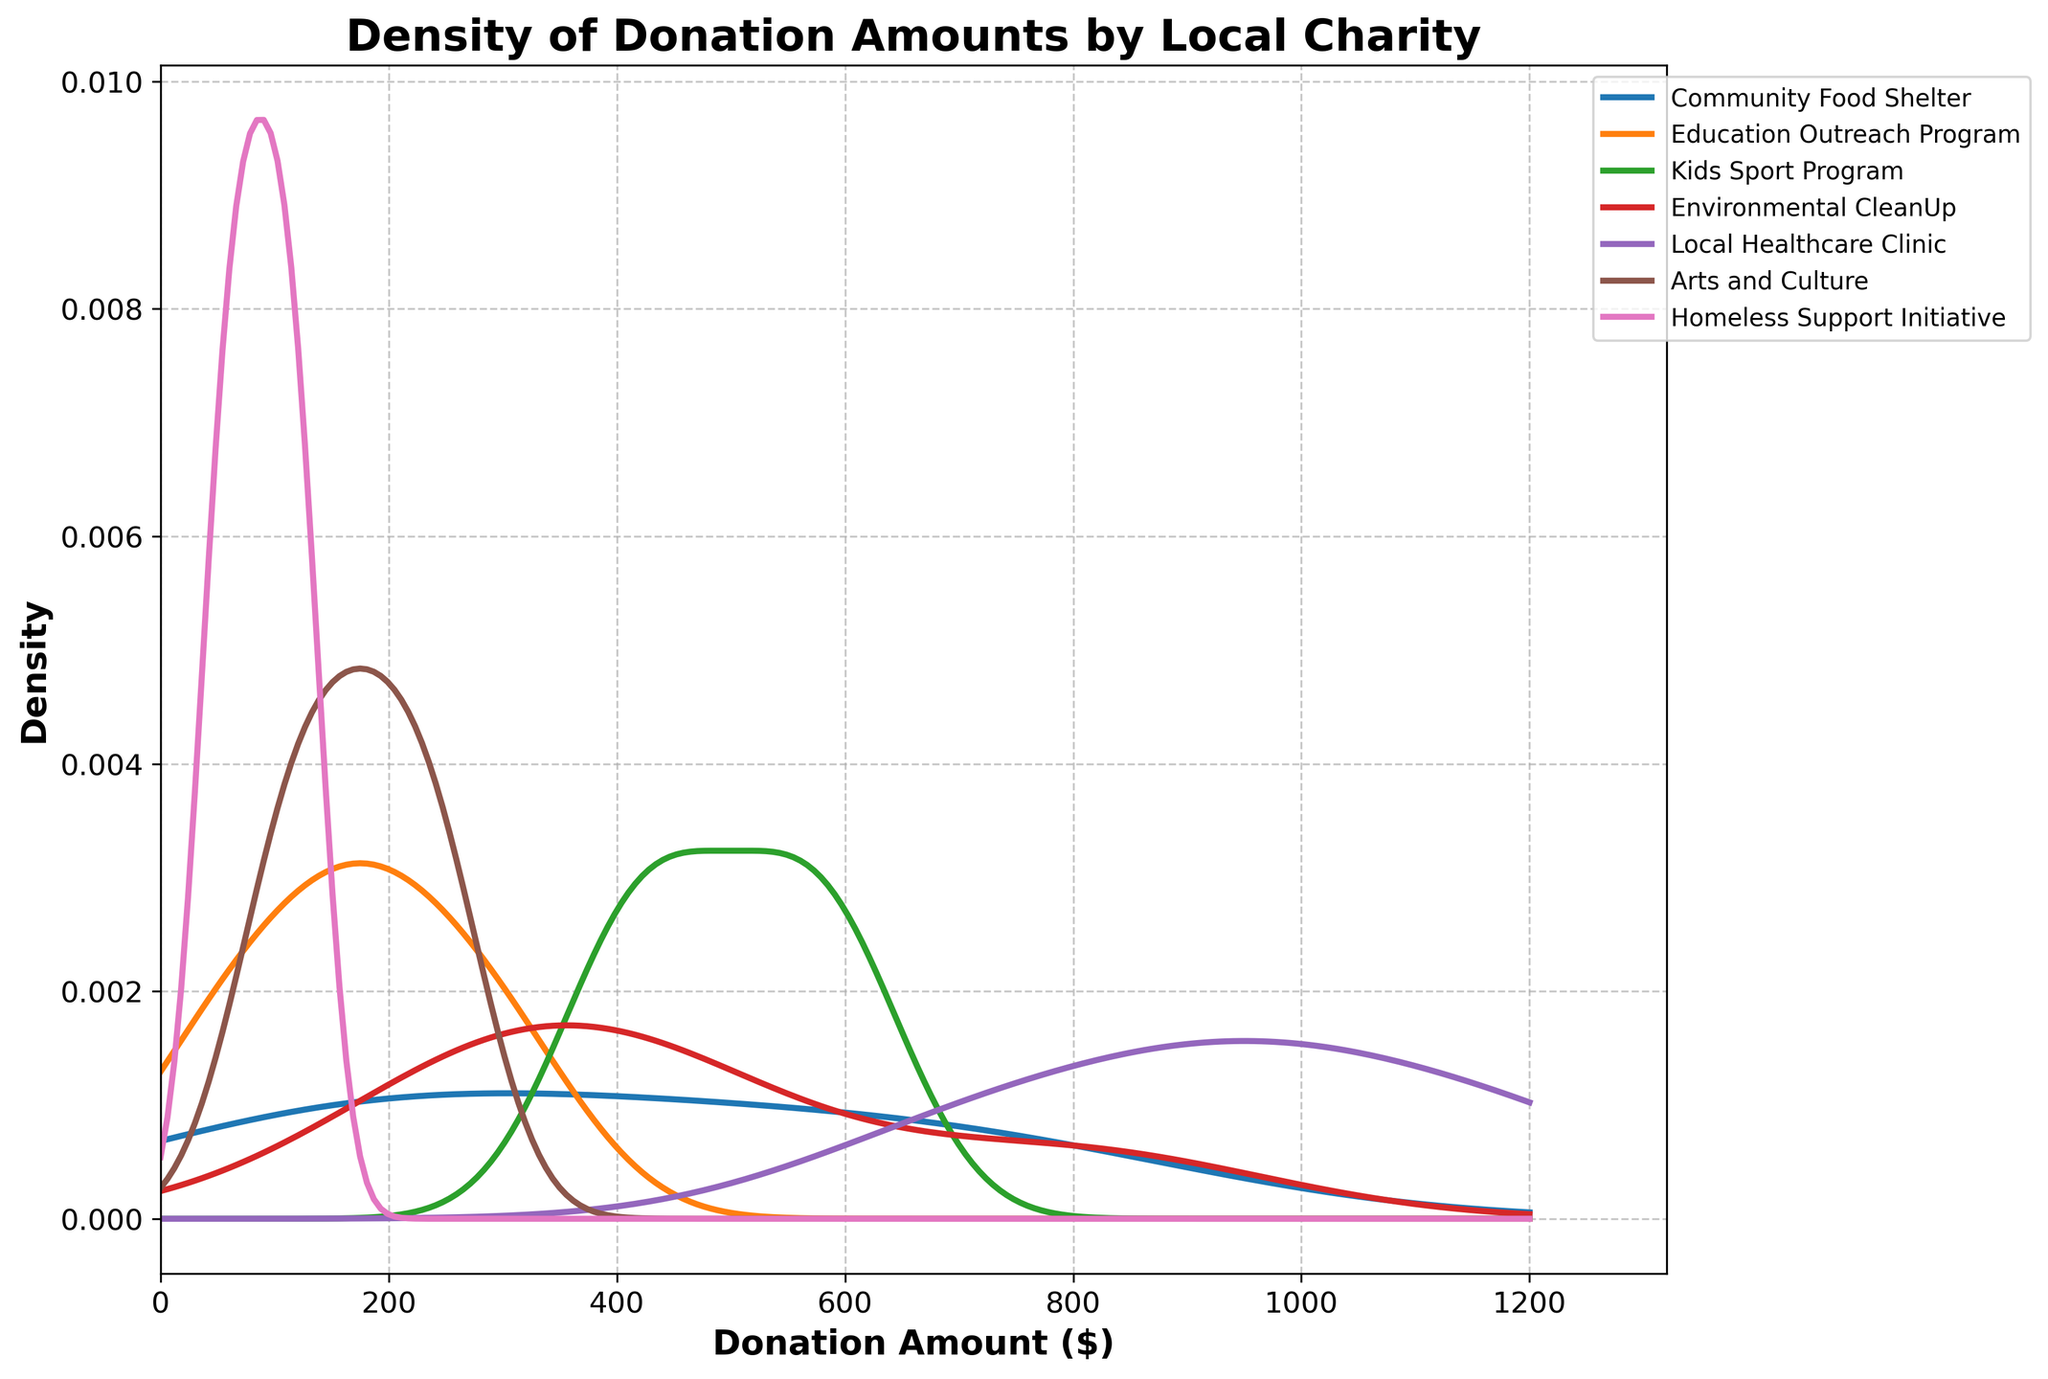What's the highest donation amount visualized in the plot? To find the highest donation amount, look at the x-axis and find the maximum value indicated.
Answer: 1200 Which charity has the highest peak density value? Examine the density plot and identify which charity's density curve reaches the highest point on the y-axis.
Answer: Local Healthcare Clinic How does the donation distribution for the Community Food Shelter compare to that for the Arts and Culture initiative? Identify the peak and spread of the density curves for both the Community Food Shelter and the Arts and Culture initiative. Note the position and height of the curves.
Answer: Community Food Shelter's donations are higher and more spread out than Arts and Culture's For which charity is the donation distribution most spread out? Look at the width of the density plot for each charity to see which curve covers the widest range on the x-axis.
Answer: Local Healthcare Clinic What donation amount range has the highest density for the Education Outreach Program? Find the peak of the Education Outreach Program's density curve on the plot, then identify the corresponding range on the x-axis.
Answer: 150 to 300 Which charity has the most concentrated donation amounts around a specific value? Locate the density curve that has the sharpest peak, indicating a concentration around a specific value.
Answer: Arts and Culture How does the donation distribution for the Kids Sport Program compare to the Environmental CleanUp initiative? Compare the density plots for the Kids Sport Program and Environmental CleanUp initiative in terms of height (max density) and spread (range of donation amounts).
Answer: Kids Sport Program's distribution is higher and narrower than Environmental CleanUp's What's the approximate donation amount where the density is highest for the Homeless Support Initiative? Identify the peak of the Homeless Support Initiative's density curve and the corresponding donation amount on the x-axis.
Answer: 75 Based on the density plots, which charities have their donation amounts peaking under 200 dollars? Look at the peaks of each charity's density curve and note which peaks are positioned below the 200-dollar mark on the x-axis.
Answer: Education Outreach Program, Arts and Culture, Homeless Support Initiative 